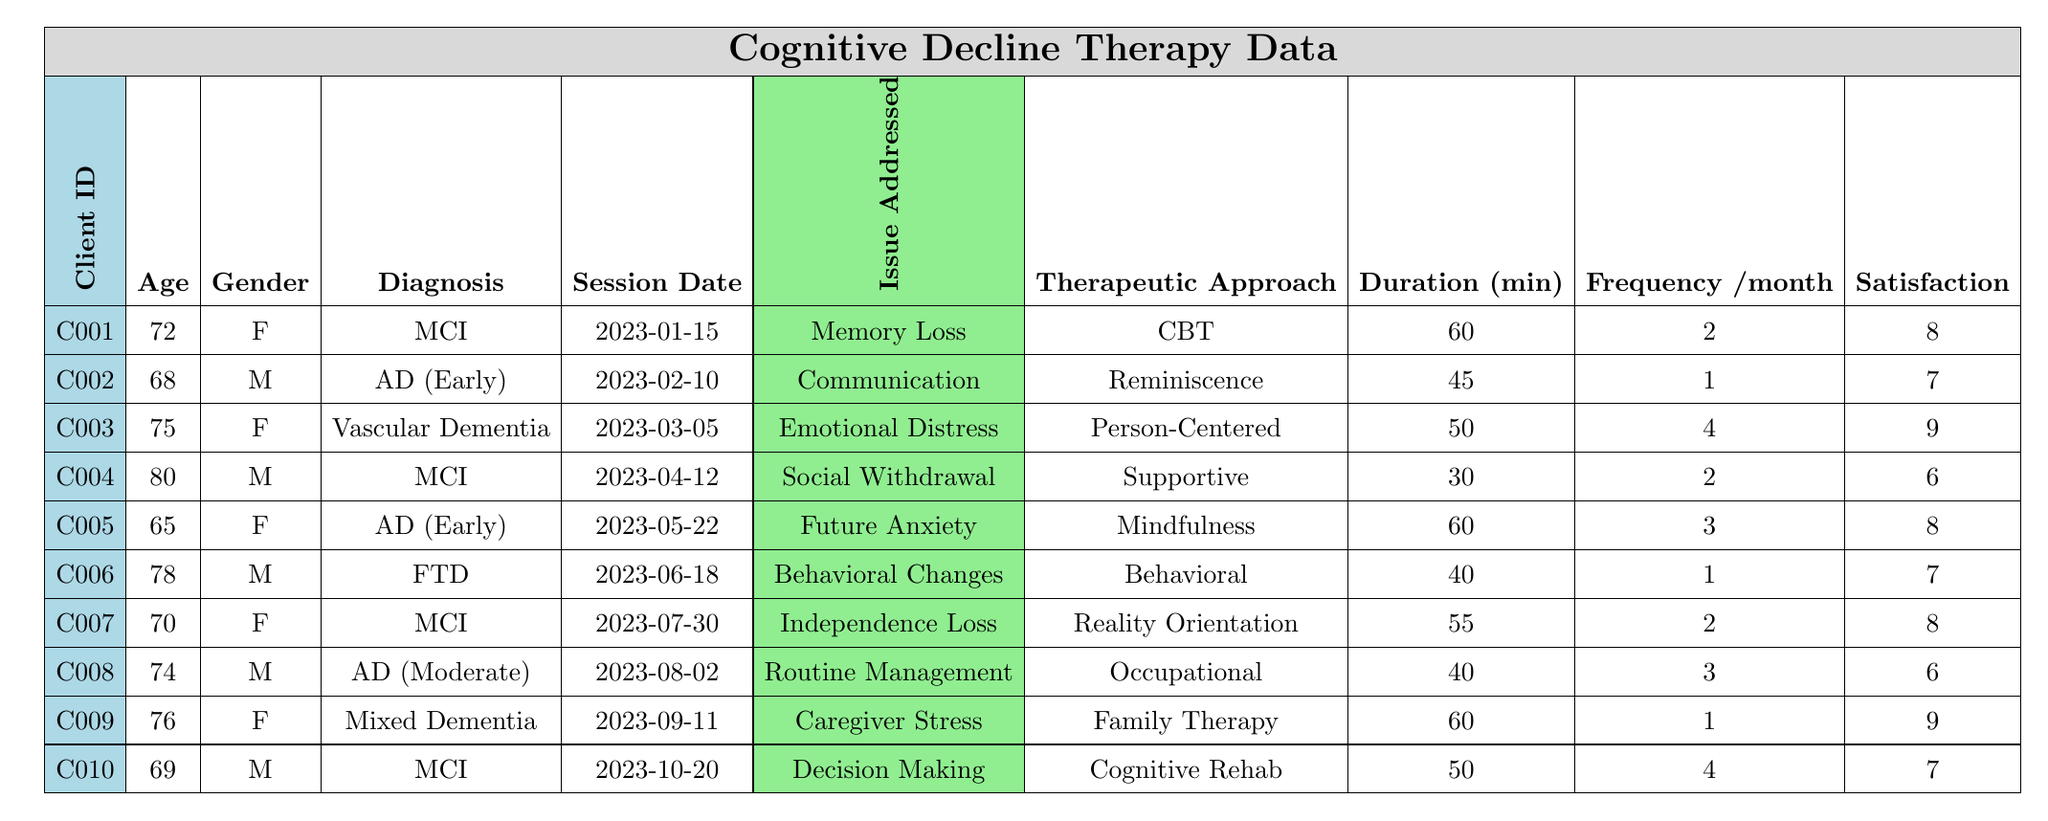What are the issues addressed in therapy sessions? The table lists various issues addressed in therapy sessions, including Memory Loss, Difficulty with Communication, Emotional Distress, Social Withdrawal, Anxiety about Future, Behavioral Changes, Loss of Independence, Daily Routine Management, Coping with Caregiver Stress, and Difficulty in Decision Making.
Answer: Memory Loss, Difficulty with Communication, Emotional Distress, Social Withdrawal, Anxiety about Future, Behavioral Changes, Loss of Independence, Daily Routine Management, Coping with Caregiver Stress, Difficulty in Decision Making How many clients are female? By counting the rows with 'F' in the Gender column, we see there are 5 female clients (C001, C003, C005, C007, C009).
Answer: 5 What was the session duration for the longest session? Looking at the Duration column, the longest session is 60 minutes, which is indicated for three sessions: Memory Loss, Anxiety about Future, and Coping with Caregiver Stress.
Answer: 60 minutes What is the average client satisfaction score? The satisfaction scores are: 8, 7, 9, 6, 8, 7, 8, 6, 9, and 7. Summing these gives us 79. Dividing by the number of clients (10) gives an average of 7.9.
Answer: 7.9 Is there a client who addressed “Loss of Independence”? Yes, Client C007 has addressed the issue of Loss of Independence in their therapy session.
Answer: Yes Which therapeutic approach was used most frequently? The approaches are: CBT, Reminiscence Therapy, Person-Centered Therapy, Supportive Psychotherapy, Mindfulness-Based Stress Reduction, Behavioral Therapy, Reality Orientation, Occupational Therapy, Family Therapy, and Cognitive Rehabilitation. Each approach appears only once, so there's no dominant approach in terms of frequency.
Answer: No dominant approach Which age group of clients has the highest frequency per month for sessions? Analyzing the Frequency column, the clients aged 75 (C003) and 69 (C010) have the highest frequency of 4 sessions per month, both addressing different issues.
Answer: Age group 75 and 69 What percentage of clients have Alzheimer's Disease? There are 3 clients with 'Alzheimer's Disease' out of a total of 10 clients. To find the percentage: (3/10) * 100 = 30%.
Answer: 30% How many clients reported Emotional Distress? Only one client (C003) reported Emotional Distress as the issue addressed in therapy.
Answer: 1 Which client had the highest session duration and what issue was addressed? The highest session duration of 60 minutes was for two clients: C001 (Memory Loss) and C005 (Anxiety about Future).
Answer: C001 and C005, Memory Loss and Anxiety about Future respectively Which therapeutic approach had the lowest satisfaction score? The therapeutic approach with the lowest satisfaction score is Supportive Psychotherapy, which received a score of 6 from client C004.
Answer: Supportive Psychotherapy with a score of 6 